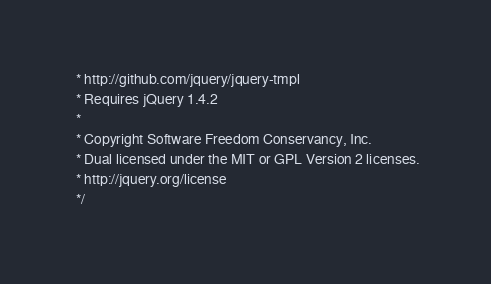<code> <loc_0><loc_0><loc_500><loc_500><_HTML_> * http://github.com/jquery/jquery-tmpl
 * Requires jQuery 1.4.2
 *
 * Copyright Software Freedom Conservancy, Inc.
 * Dual licensed under the MIT or GPL Version 2 licenses.
 * http://jquery.org/license
 */</code> 